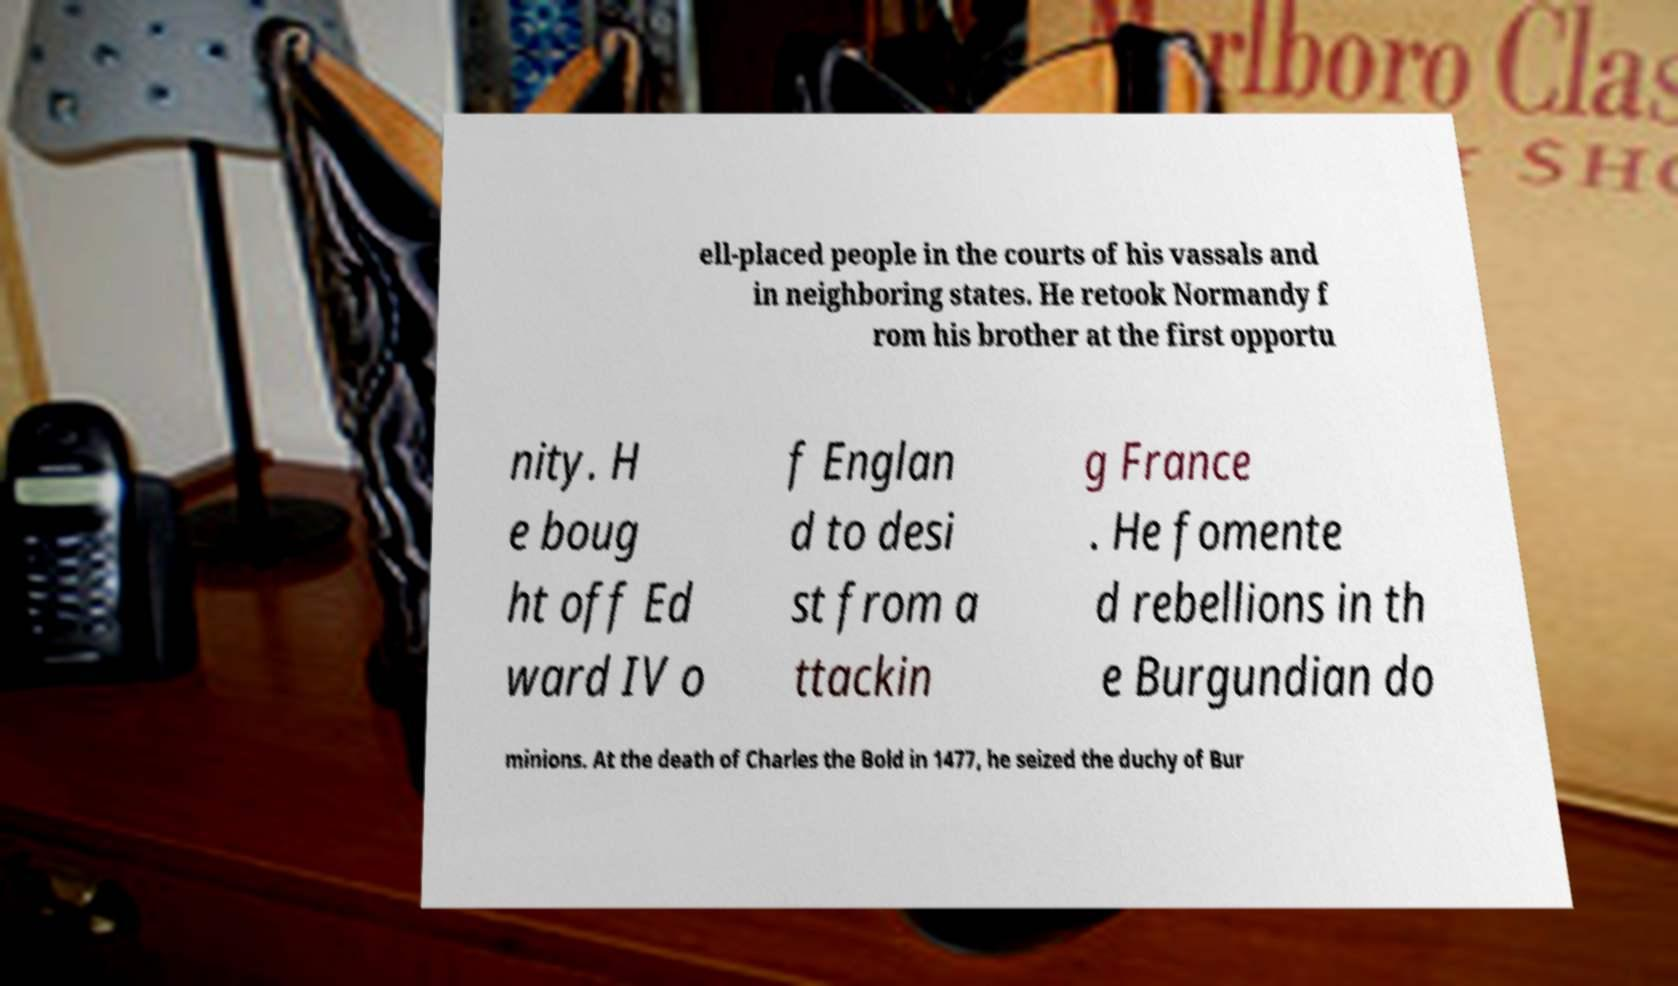What messages or text are displayed in this image? I need them in a readable, typed format. ell-placed people in the courts of his vassals and in neighboring states. He retook Normandy f rom his brother at the first opportu nity. H e boug ht off Ed ward IV o f Englan d to desi st from a ttackin g France . He fomente d rebellions in th e Burgundian do minions. At the death of Charles the Bold in 1477, he seized the duchy of Bur 